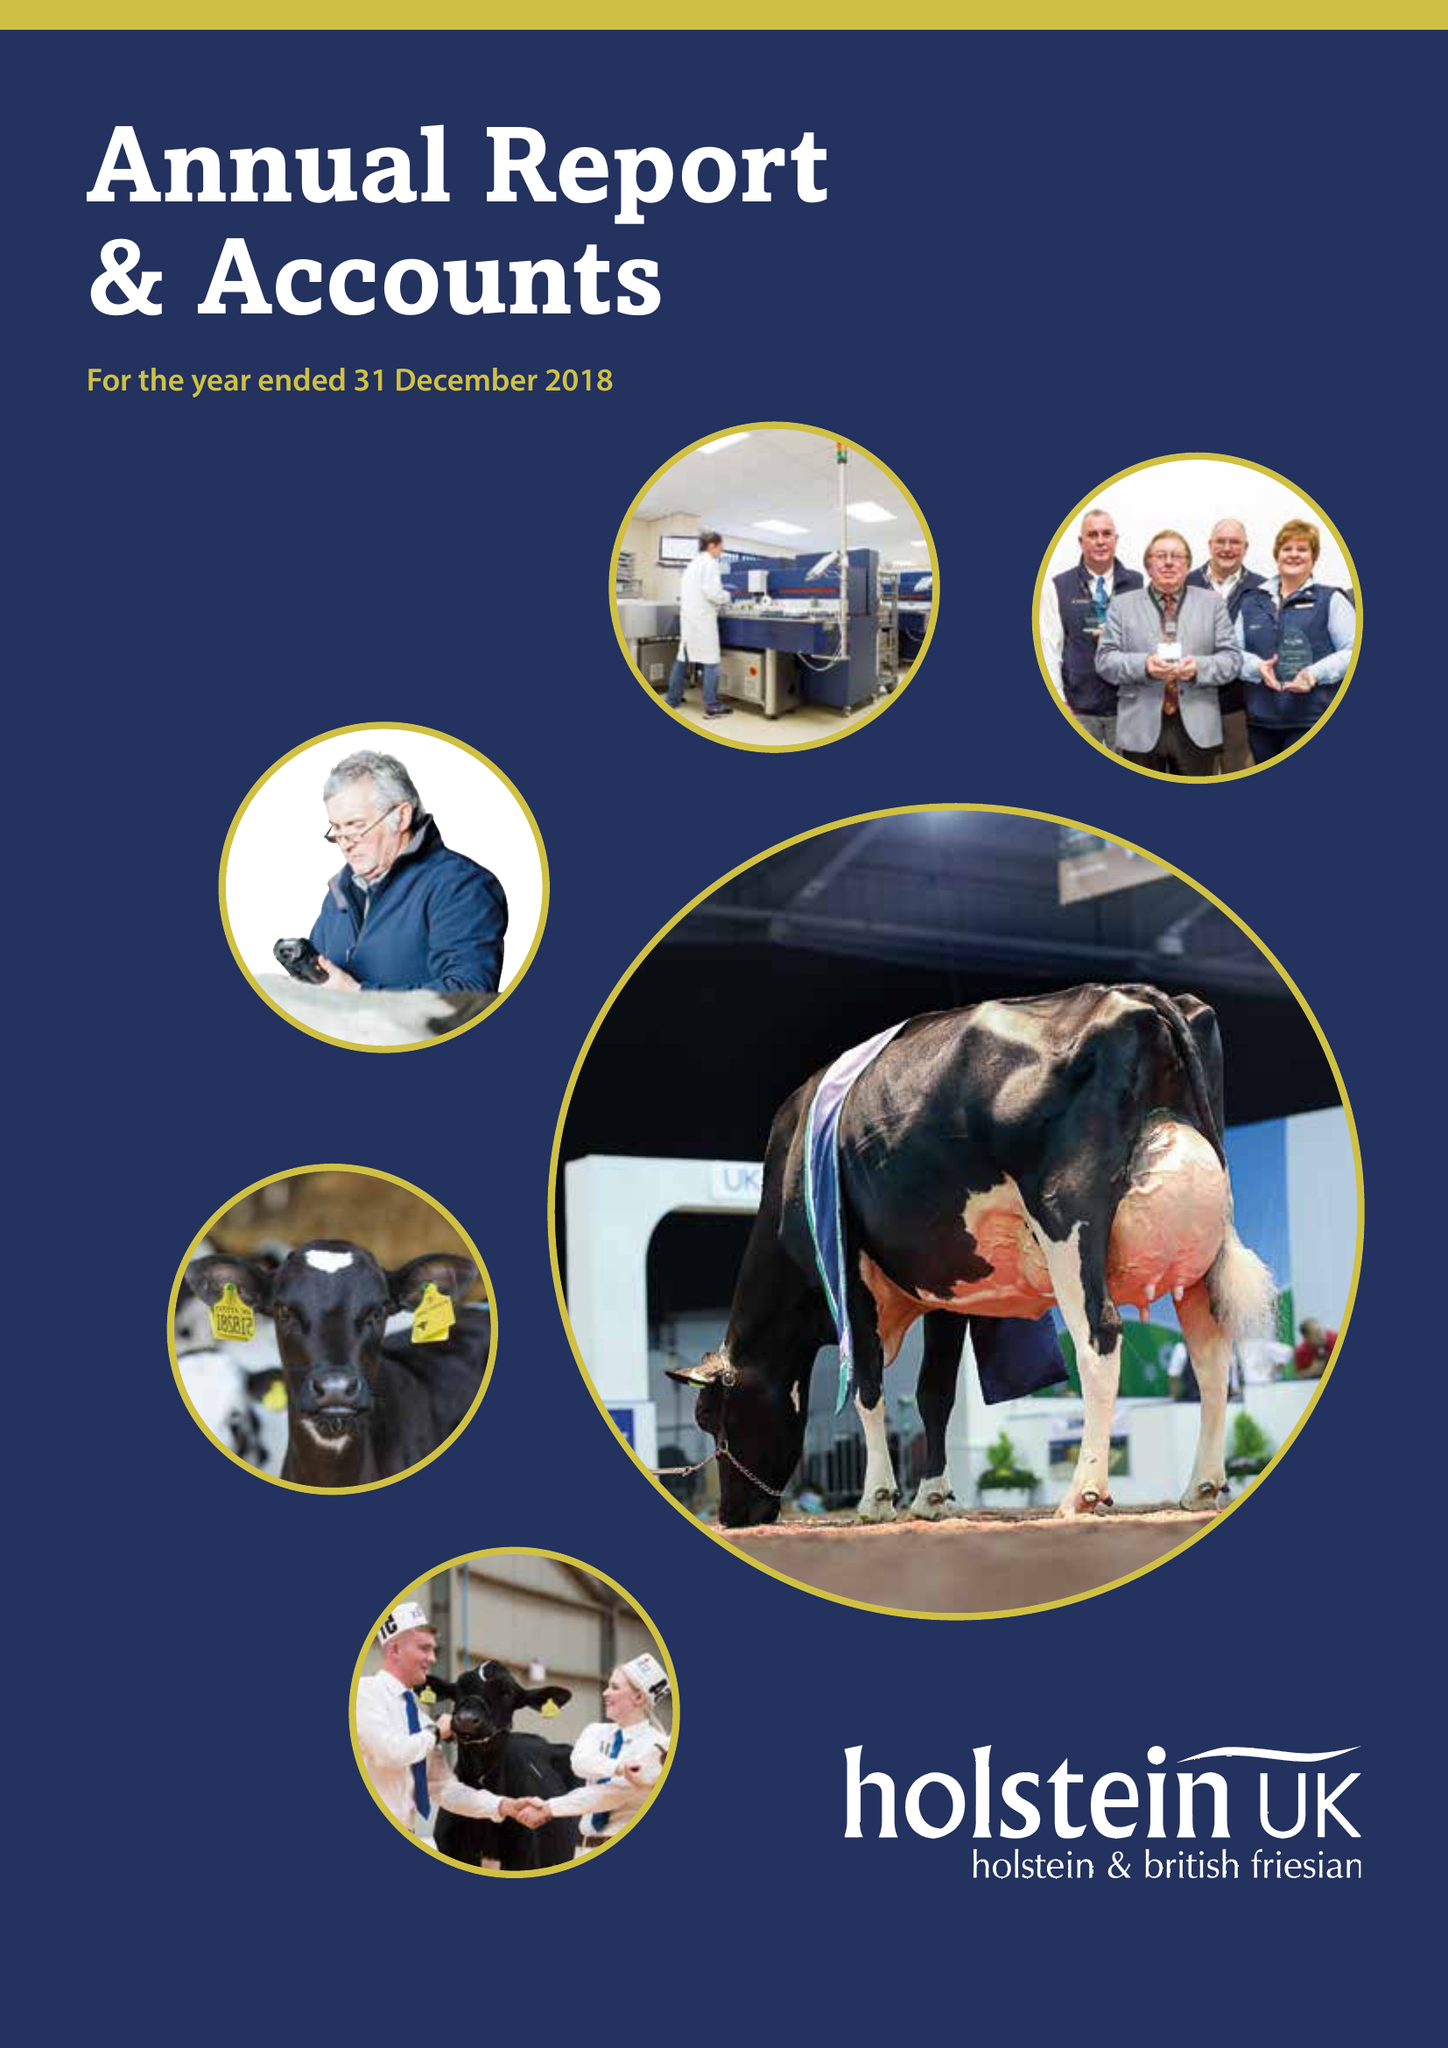What is the value for the charity_name?
Answer the question using a single word or phrase. Holstein Uk 